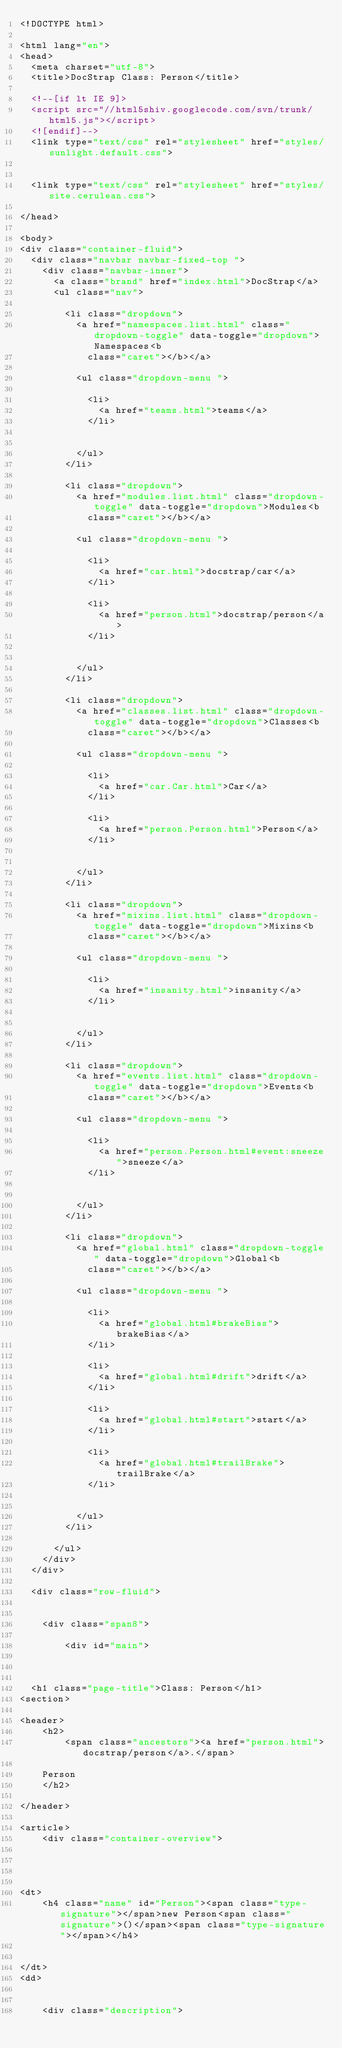<code> <loc_0><loc_0><loc_500><loc_500><_HTML_><!DOCTYPE html>

<html lang="en">
<head>
	<meta charset="utf-8">
	<title>DocStrap Class: Person</title>

	<!--[if lt IE 9]>
	<script src="//html5shiv.googlecode.com/svn/trunk/html5.js"></script>
	<![endif]-->
	<link type="text/css" rel="stylesheet" href="styles/sunlight.default.css">

	
	<link type="text/css" rel="stylesheet" href="styles/site.cerulean.css">
	
</head>

<body>
<div class="container-fluid">
	<div class="navbar navbar-fixed-top ">
		<div class="navbar-inner">
			<a class="brand" href="index.html">DocStrap</a>
			<ul class="nav">
				
				<li class="dropdown">
					<a href="namespaces.list.html" class="dropdown-toggle" data-toggle="dropdown">Namespaces<b
						class="caret"></b></a>

					<ul class="dropdown-menu ">
						
						<li>
							<a href="teams.html">teams</a>
						</li>
						

					</ul>
				</li>
				
				<li class="dropdown">
					<a href="modules.list.html" class="dropdown-toggle" data-toggle="dropdown">Modules<b
						class="caret"></b></a>

					<ul class="dropdown-menu ">
						
						<li>
							<a href="car.html">docstrap/car</a>
						</li>
						
						<li>
							<a href="person.html">docstrap/person</a>
						</li>
						

					</ul>
				</li>
				
				<li class="dropdown">
					<a href="classes.list.html" class="dropdown-toggle" data-toggle="dropdown">Classes<b
						class="caret"></b></a>

					<ul class="dropdown-menu ">
						
						<li>
							<a href="car.Car.html">Car</a>
						</li>
						
						<li>
							<a href="person.Person.html">Person</a>
						</li>
						

					</ul>
				</li>
				
				<li class="dropdown">
					<a href="mixins.list.html" class="dropdown-toggle" data-toggle="dropdown">Mixins<b
						class="caret"></b></a>

					<ul class="dropdown-menu ">
						
						<li>
							<a href="insanity.html">insanity</a>
						</li>
						

					</ul>
				</li>
				
				<li class="dropdown">
					<a href="events.list.html" class="dropdown-toggle" data-toggle="dropdown">Events<b
						class="caret"></b></a>

					<ul class="dropdown-menu ">
						
						<li>
							<a href="person.Person.html#event:sneeze">sneeze</a>
						</li>
						

					</ul>
				</li>
				
				<li class="dropdown">
					<a href="global.html" class="dropdown-toggle" data-toggle="dropdown">Global<b
						class="caret"></b></a>

					<ul class="dropdown-menu ">
						
						<li>
							<a href="global.html#brakeBias">brakeBias</a>
						</li>
						
						<li>
							<a href="global.html#drift">drift</a>
						</li>
						
						<li>
							<a href="global.html#start">start</a>
						</li>
						
						<li>
							<a href="global.html#trailBrake">trailBrake</a>
						</li>
						

					</ul>
				</li>
				
			</ul>
		</div>
	</div>

	<div class="row-fluid">

		
		<div class="span8">
			
				<div id="main">
					


	<h1 class="page-title">Class: Person</h1>
<section>

<header>
    <h2>
        <span class="ancestors"><a href="person.html">docstrap/person</a>.</span>
    
    Person
    </h2>
    
</header>

<article>
    <div class="container-overview">
    

    
        
<dt>
    <h4 class="name" id="Person"><span class="type-signature"></span>new Person<span class="signature">()</span><span class="type-signature"></span></h4>
    
    
</dt>
<dd>
    
    
    <div class="description"></code> 